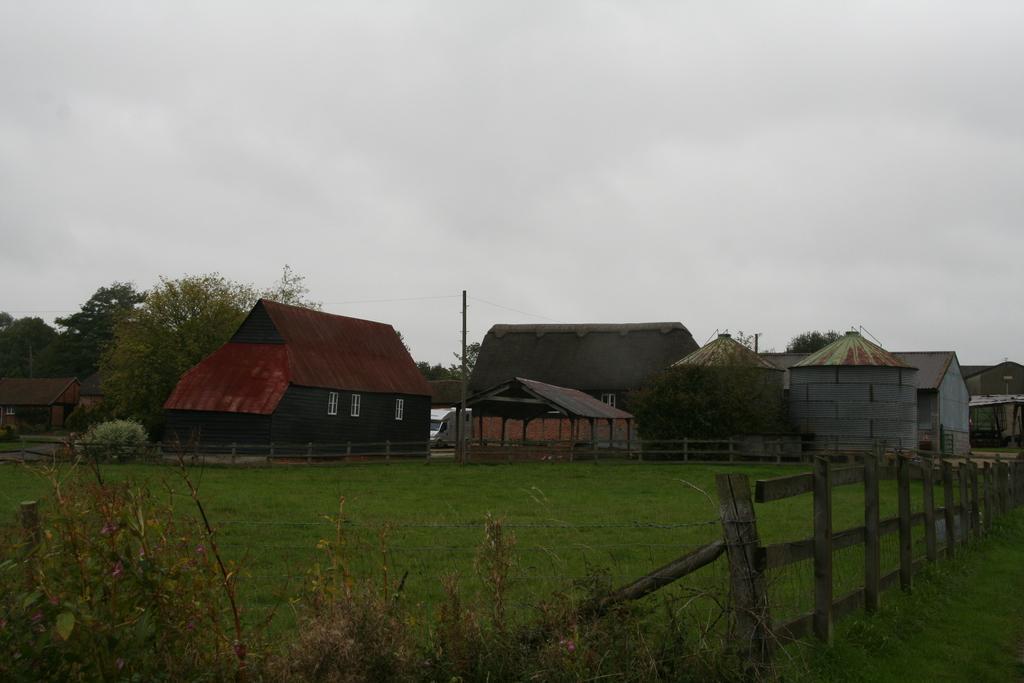Please provide a concise description of this image. In this image there are some few houses and fence, pole is visible in the middle, at the top there is the sky. 